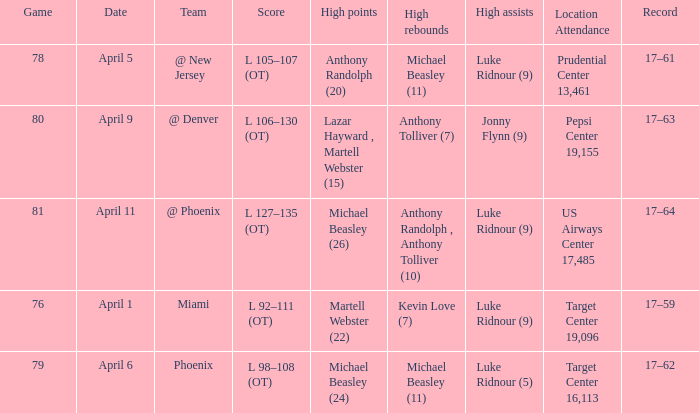Who did the most high rebounds on April 6? Michael Beasley (11). 